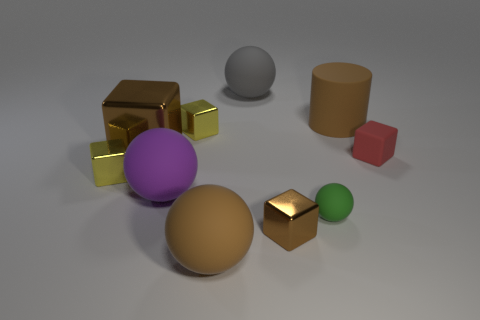What shape is the large purple thing that is the same material as the large gray object?
Your answer should be compact. Sphere. There is a ball behind the object that is right of the cylinder; how big is it?
Your answer should be very brief. Large. What number of small blocks are the same color as the big metallic object?
Offer a terse response. 1. What material is the brown object that is both right of the big metal block and behind the green sphere?
Keep it short and to the point. Rubber. There is a block that is to the right of the green ball; is it the same color as the matte ball that is left of the large brown matte ball?
Offer a very short reply. No. How many red objects are either big cylinders or small metal things?
Provide a succinct answer. 0. Are there fewer small metallic objects behind the small green matte ball than tiny red matte objects that are behind the large gray rubber thing?
Offer a very short reply. No. Is there a purple matte ball that has the same size as the matte cylinder?
Make the answer very short. Yes. Is the size of the matte ball left of the brown sphere the same as the matte block?
Your response must be concise. No. Is the number of yellow rubber things greater than the number of brown rubber cylinders?
Your answer should be very brief. No. 